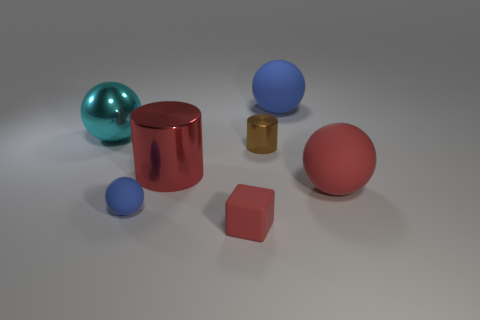Subtract all tiny blue matte spheres. How many spheres are left? 3 Add 3 tiny brown things. How many objects exist? 10 Subtract all balls. How many objects are left? 3 Subtract 1 blocks. How many blocks are left? 0 Subtract all blue cubes. Subtract all gray balls. How many cubes are left? 1 Subtract all red blocks. How many brown balls are left? 0 Subtract all rubber things. Subtract all shiny spheres. How many objects are left? 2 Add 7 large blue objects. How many large blue objects are left? 8 Add 2 small yellow metal cylinders. How many small yellow metal cylinders exist? 2 Subtract all cyan spheres. How many spheres are left? 3 